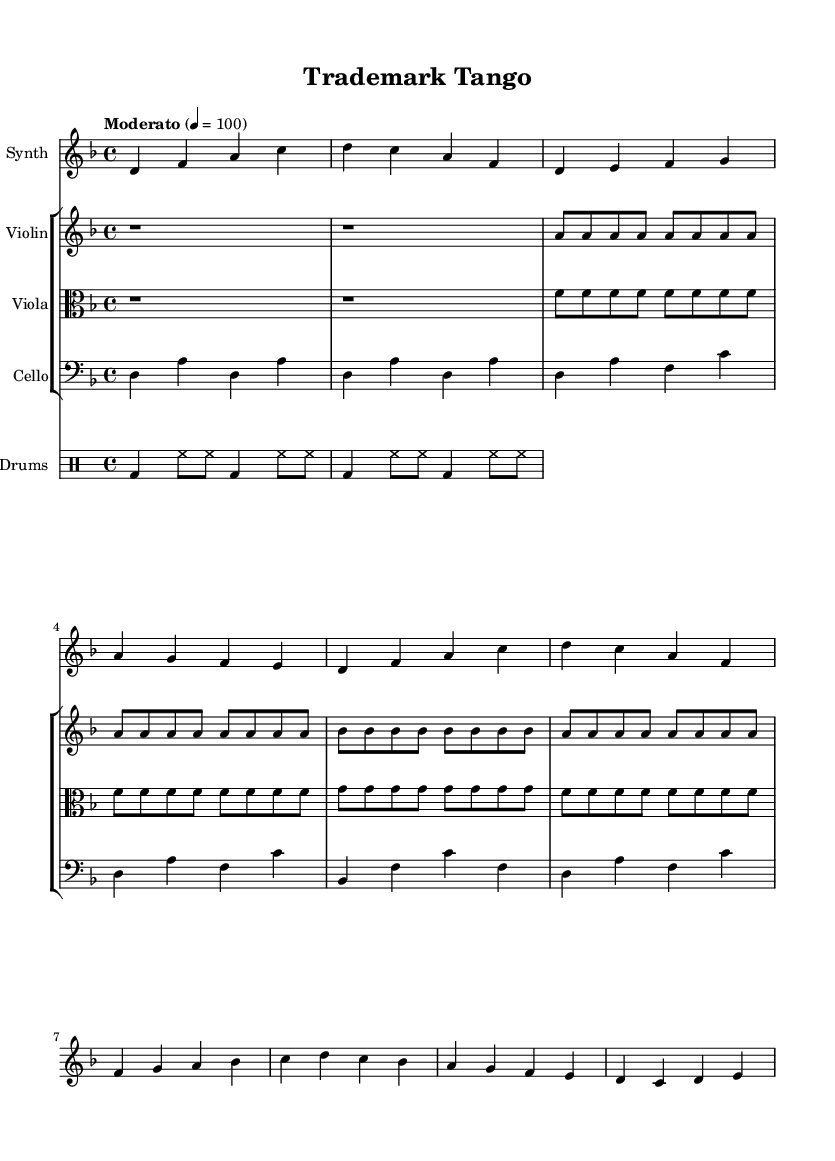What is the key signature of this music? The key signature is indicated at the beginning of the staff. In this case, it shows two flats (B♭ and E♭), which leads to the conclusion that the key is D minor.
Answer: D minor What is the time signature of this music? The time signature appears right after the key signature at the beginning of the score. It indicates that there are four beats per measure, which is shown as 4/4.
Answer: 4/4 What is the tempo marking for this piece? The tempo marking is located in the header section of the score, specifying how fast the piece should be played. It states "Moderato" with a metronome marking of quarter note equals 100.
Answer: Moderato How many measures are there in the synth part? By counting the individual measures in the synth line, we can determine the total. The synth part shows a total of eight measures.
Answer: 8 Which instruments are included in the ensemble? Looking at the score, the instruments are listed above each staff. There are four named instruments: Synth, Violin, Viola, and Cello.
Answer: Synth, Violin, Viola, Cello What is the rhythmic pattern in the drum part? By analyzing the drum staff, we can see the specific pattern. It consists of a bass drum on the first and third beats with hi-hat played on the eighth notes, repeating twice.
Answer: Bass drum and hi-hat What is the main theme of the violin part? The violin part is identified as playing sustained quarter notes, emphasizing repeated pitches. It has a consistent repetition of the note A throughout its measures, creating a stable theme.
Answer: Sustained A notes 